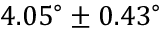<formula> <loc_0><loc_0><loc_500><loc_500>4 . 0 5 ^ { \circ } \pm 0 . 4 3 ^ { \circ }</formula> 